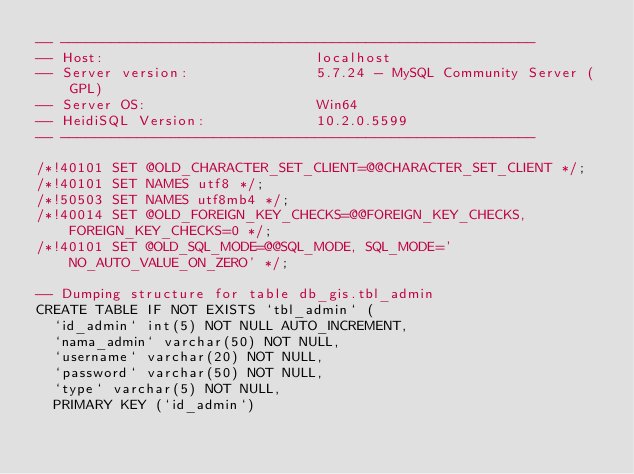<code> <loc_0><loc_0><loc_500><loc_500><_SQL_>-- --------------------------------------------------------
-- Host:                         localhost
-- Server version:               5.7.24 - MySQL Community Server (GPL)
-- Server OS:                    Win64
-- HeidiSQL Version:             10.2.0.5599
-- --------------------------------------------------------

/*!40101 SET @OLD_CHARACTER_SET_CLIENT=@@CHARACTER_SET_CLIENT */;
/*!40101 SET NAMES utf8 */;
/*!50503 SET NAMES utf8mb4 */;
/*!40014 SET @OLD_FOREIGN_KEY_CHECKS=@@FOREIGN_KEY_CHECKS, FOREIGN_KEY_CHECKS=0 */;
/*!40101 SET @OLD_SQL_MODE=@@SQL_MODE, SQL_MODE='NO_AUTO_VALUE_ON_ZERO' */;

-- Dumping structure for table db_gis.tbl_admin
CREATE TABLE IF NOT EXISTS `tbl_admin` (
  `id_admin` int(5) NOT NULL AUTO_INCREMENT,
  `nama_admin` varchar(50) NOT NULL,
  `username` varchar(20) NOT NULL,
  `password` varchar(50) NOT NULL,
  `type` varchar(5) NOT NULL,
  PRIMARY KEY (`id_admin`)</code> 